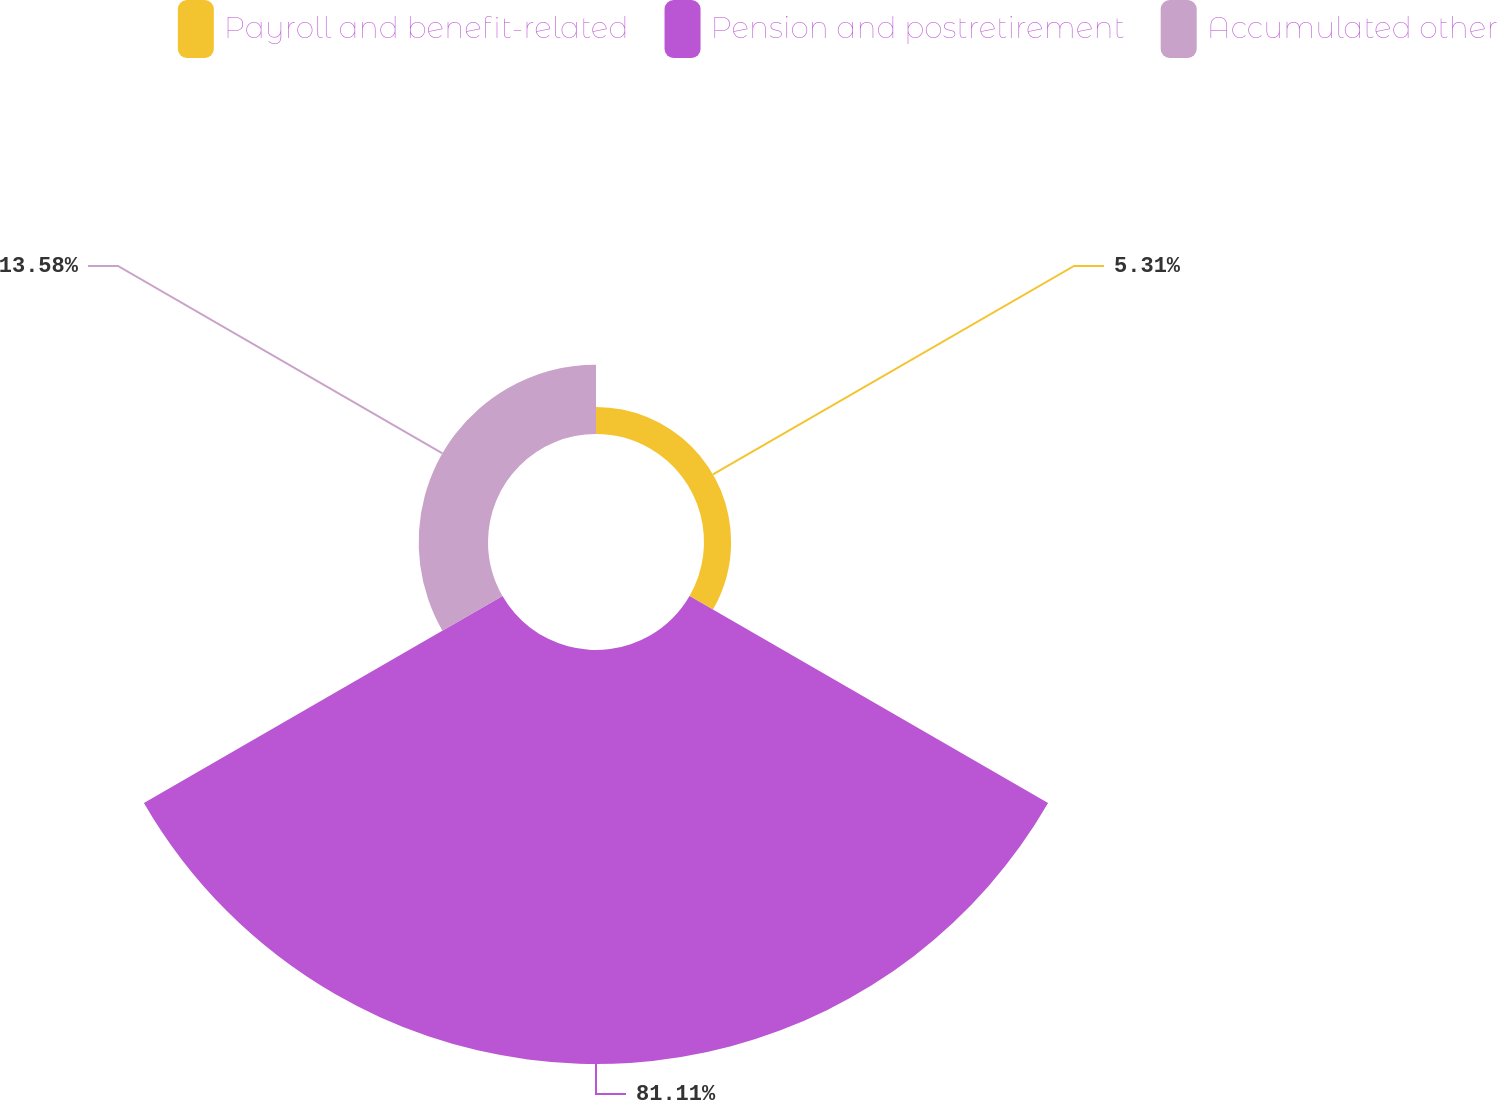Convert chart. <chart><loc_0><loc_0><loc_500><loc_500><pie_chart><fcel>Payroll and benefit-related<fcel>Pension and postretirement<fcel>Accumulated other<nl><fcel>5.31%<fcel>81.11%<fcel>13.58%<nl></chart> 